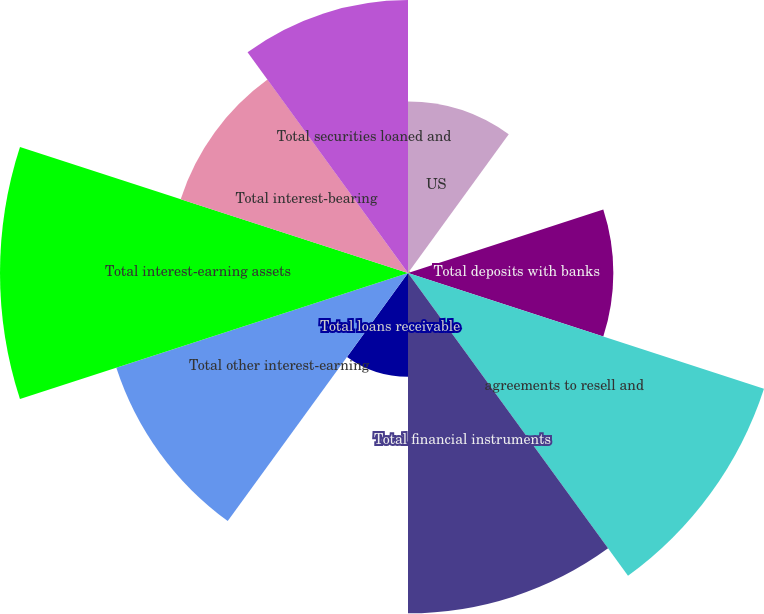Convert chart. <chart><loc_0><loc_0><loc_500><loc_500><pie_chart><fcel>US<fcel>Non-US<fcel>Total deposits with banks<fcel>agreements to resell and<fcel>Total financial instruments<fcel>Total loans receivable<fcel>Total other interest-earning<fcel>Total interest-earning assets<fcel>Total interest-bearing<fcel>Total securities loaned and<nl><fcel>7.07%<fcel>0.1%<fcel>8.47%<fcel>15.44%<fcel>14.04%<fcel>4.28%<fcel>12.65%<fcel>16.83%<fcel>9.86%<fcel>11.26%<nl></chart> 